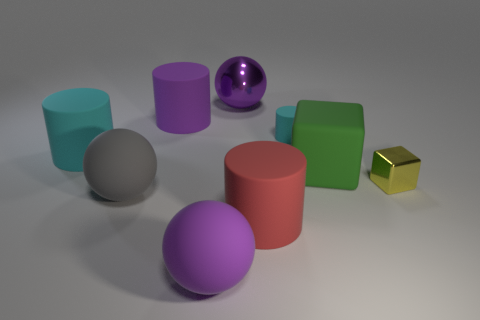There is a small thing left of the large green cube; is its color the same as the rubber object left of the gray matte object?
Your answer should be compact. Yes. Is the shape of the small metallic thing the same as the big green thing?
Your response must be concise. Yes. How many rubber things are large cubes or small cyan cylinders?
Your answer should be very brief. 2. How many small red cubes are there?
Provide a succinct answer. 0. There is a matte block that is the same size as the red object; what color is it?
Your response must be concise. Green. Does the gray rubber thing have the same size as the purple rubber sphere?
Make the answer very short. Yes. There is a green matte cube; does it have the same size as the cyan cylinder right of the red object?
Your response must be concise. No. There is a rubber cylinder that is in front of the big purple cylinder and behind the large cyan matte thing; what is its color?
Your answer should be very brief. Cyan. Is the number of cyan things in front of the big cyan matte cylinder greater than the number of tiny yellow metallic objects that are to the left of the big green rubber block?
Provide a succinct answer. No. What is the size of the cyan object that is made of the same material as the big cyan cylinder?
Provide a short and direct response. Small. 